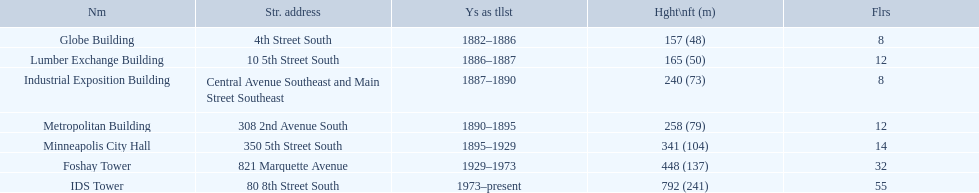What are all the building names? Globe Building, Lumber Exchange Building, Industrial Exposition Building, Metropolitan Building, Minneapolis City Hall, Foshay Tower, IDS Tower. And their heights? 157 (48), 165 (50), 240 (73), 258 (79), 341 (104), 448 (137), 792 (241). Between metropolitan building and lumber exchange building, which is taller? Metropolitan Building. 